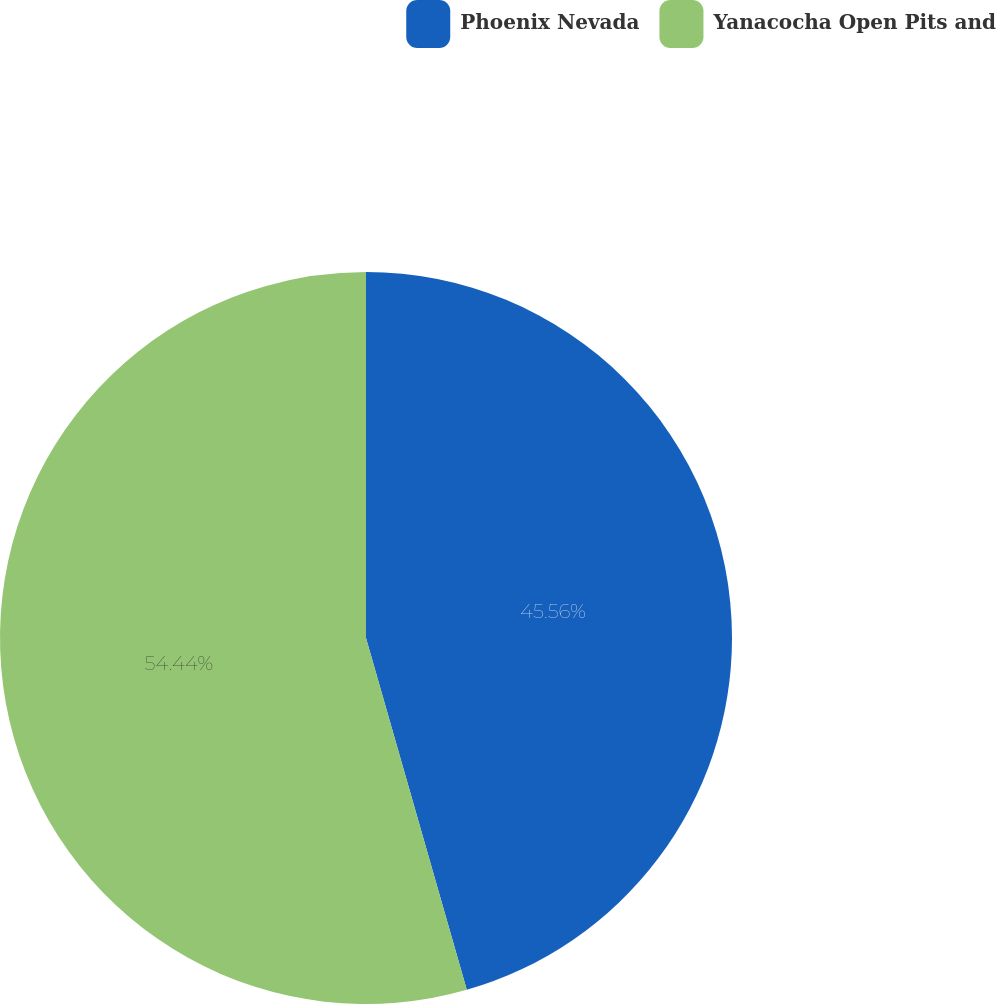<chart> <loc_0><loc_0><loc_500><loc_500><pie_chart><fcel>Phoenix Nevada<fcel>Yanacocha Open Pits and<nl><fcel>45.56%<fcel>54.44%<nl></chart> 